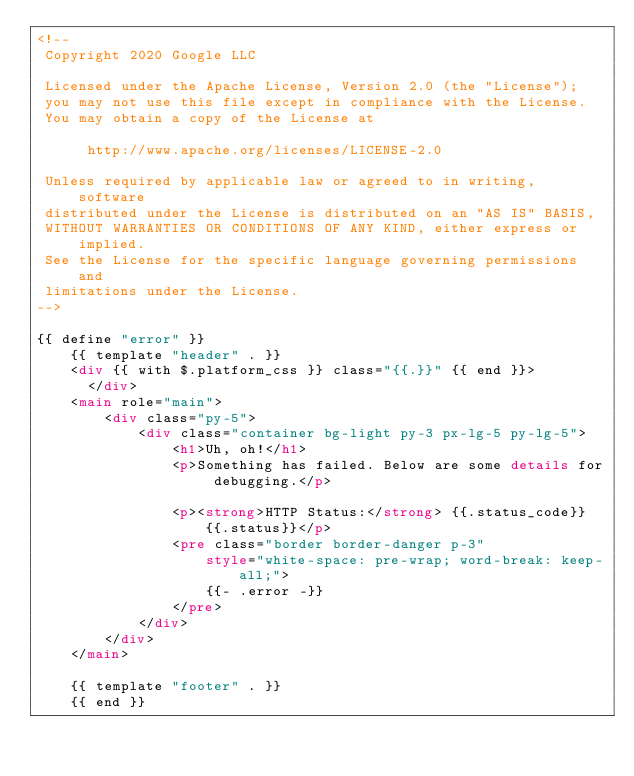Convert code to text. <code><loc_0><loc_0><loc_500><loc_500><_HTML_><!--
 Copyright 2020 Google LLC

 Licensed under the Apache License, Version 2.0 (the "License");
 you may not use this file except in compliance with the License.
 You may obtain a copy of the License at

      http://www.apache.org/licenses/LICENSE-2.0

 Unless required by applicable law or agreed to in writing, software
 distributed under the License is distributed on an "AS IS" BASIS,
 WITHOUT WARRANTIES OR CONDITIONS OF ANY KIND, either express or implied.
 See the License for the specific language governing permissions and
 limitations under the License.
-->

{{ define "error" }}
    {{ template "header" . }}
    <div {{ with $.platform_css }} class="{{.}}" {{ end }}>
      </div>
    <main role="main">
        <div class="py-5">
            <div class="container bg-light py-3 px-lg-5 py-lg-5">
                <h1>Uh, oh!</h1>
                <p>Something has failed. Below are some details for debugging.</p>

                <p><strong>HTTP Status:</strong> {{.status_code}} {{.status}}</p>
                <pre class="border border-danger p-3"
                    style="white-space: pre-wrap; word-break: keep-all;">
                    {{- .error -}}
                </pre>
            </div>
        </div>
    </main>

    {{ template "footer" . }}
    {{ end }}
</code> 